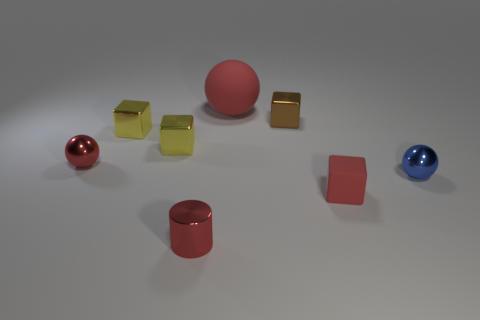What materials are the objects in the image made of? The objects appear to consist of two types of materials: metallic for the shiny, reflective surfaces, and rubbery for the matte surfaces.  Are there any patterns or symmetry in the arrangement of these objects? The objects are arranged without a strict pattern, but there is a balance with three types of objects each in two colors, red and yellow, distributed across the scene, providing a visual symmetry in color and form. 